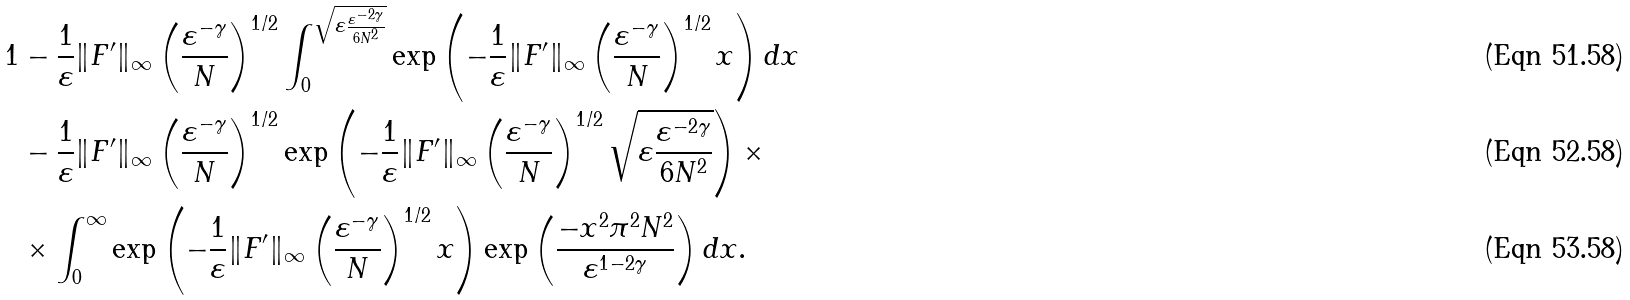<formula> <loc_0><loc_0><loc_500><loc_500>1 & - \frac { 1 } { \varepsilon } \| F ^ { \prime } \| _ { \infty } \left ( \frac { \varepsilon ^ { - \gamma } } { N } \right ) ^ { 1 / 2 } \int _ { 0 } ^ { \sqrt { \varepsilon \frac { \varepsilon ^ { - 2 \gamma } } { 6 N ^ { 2 } } } } \exp \left ( - \frac { 1 } { \varepsilon } \| F ^ { \prime } \| _ { \infty } \left ( \frac { \varepsilon ^ { - \gamma } } { N } \right ) ^ { 1 / 2 } x \right ) d x \\ & - \frac { 1 } { \varepsilon } \| F ^ { \prime } \| _ { \infty } \left ( \frac { \varepsilon ^ { - \gamma } } { N } \right ) ^ { 1 / 2 } \exp \left ( - \frac { 1 } { \varepsilon } \| F ^ { \prime } \| _ { \infty } \left ( \frac { \varepsilon ^ { - \gamma } } { N } \right ) ^ { 1 / 2 } \sqrt { \varepsilon \frac { \varepsilon ^ { - 2 \gamma } } { 6 N ^ { 2 } } } \right ) \times \\ & \times \int _ { 0 } ^ { \infty } \exp \left ( - \frac { 1 } { \varepsilon } \| F ^ { \prime } \| _ { \infty } \left ( \frac { \varepsilon ^ { - \gamma } } { N } \right ) ^ { 1 / 2 } x \right ) \exp \left ( \frac { - x ^ { 2 } \pi ^ { 2 } N ^ { 2 } } { \varepsilon ^ { 1 - 2 \gamma } } \right ) d x .</formula> 